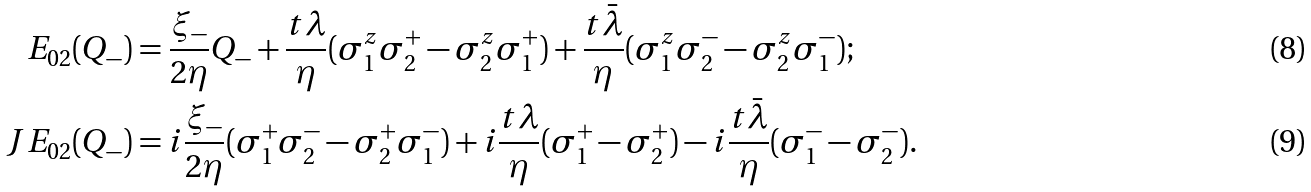Convert formula to latex. <formula><loc_0><loc_0><loc_500><loc_500>E _ { 0 2 } ( Q _ { - } ) & = \frac { \xi _ { - } } { 2 \eta } Q _ { - } + \frac { t \lambda } { \eta } ( \sigma ^ { z } _ { 1 } \sigma ^ { + } _ { 2 } - \sigma ^ { z } _ { 2 } \sigma ^ { + } _ { 1 } ) + \frac { t \bar { \lambda } } { \eta } ( \sigma ^ { z } _ { 1 } \sigma ^ { - } _ { 2 } - \sigma ^ { z } _ { 2 } \sigma ^ { - } _ { 1 } ) ; \\ J E _ { 0 2 } ( Q _ { - } ) & = i \frac { \xi _ { - } } { 2 \eta } ( \sigma ^ { + } _ { 1 } \sigma ^ { - } _ { 2 } - \sigma ^ { + } _ { 2 } \sigma ^ { - } _ { 1 } ) + i \frac { t \lambda } { \eta } ( \sigma ^ { + } _ { 1 } - \sigma ^ { + } _ { 2 } ) - i \frac { t \bar { \lambda } } { \eta } ( \sigma ^ { - } _ { 1 } - \sigma ^ { - } _ { 2 } ) .</formula> 